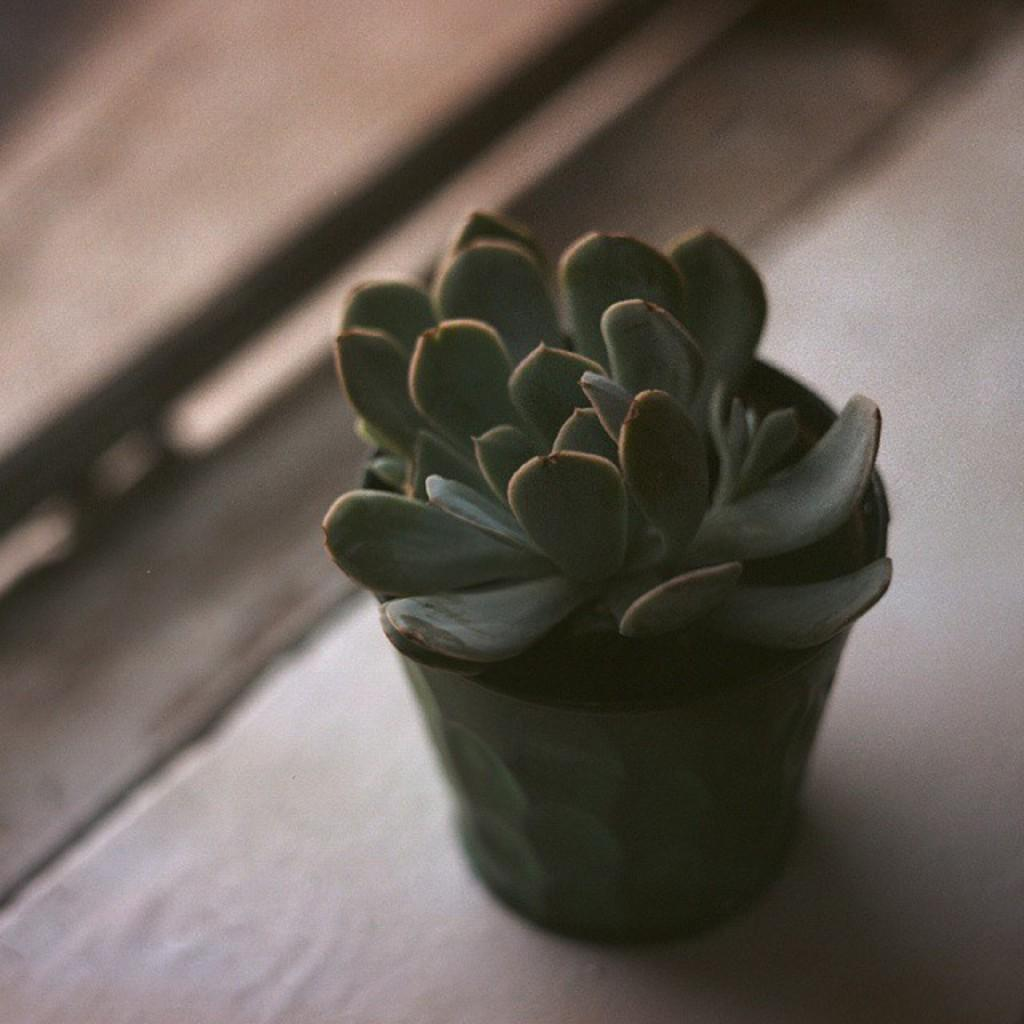What is the main subject in the center of the image? There is a plant pot in the center of the image. What is inside the plant pot? There is a plant in the plant pot. What else can be seen in the image besides the plant pot and plant? There are other objects visible in the background of the image. What type of building can be seen in the background of the image? There is no building visible in the background of the image. How does the yak contribute to the growth of the plant in the image? There is no yak present in the image, so it cannot contribute to the growth of the plant. 